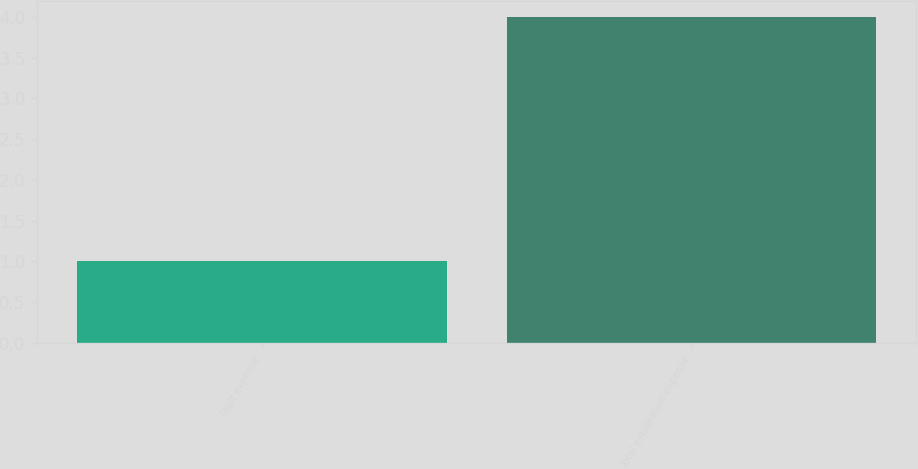Convert chart to OTSL. <chart><loc_0><loc_0><loc_500><loc_500><bar_chart><fcel>Staff expense<fcel>Total exploration expense<nl><fcel>1<fcel>4<nl></chart> 